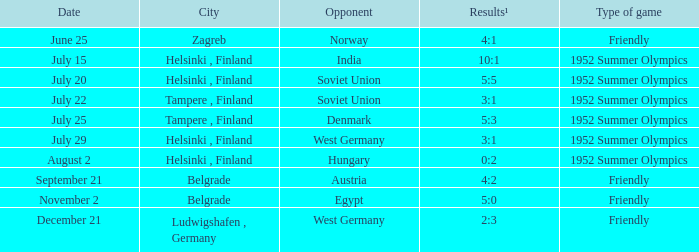What Type of game has a Results¹ of 10:1? 1952 Summer Olympics. 